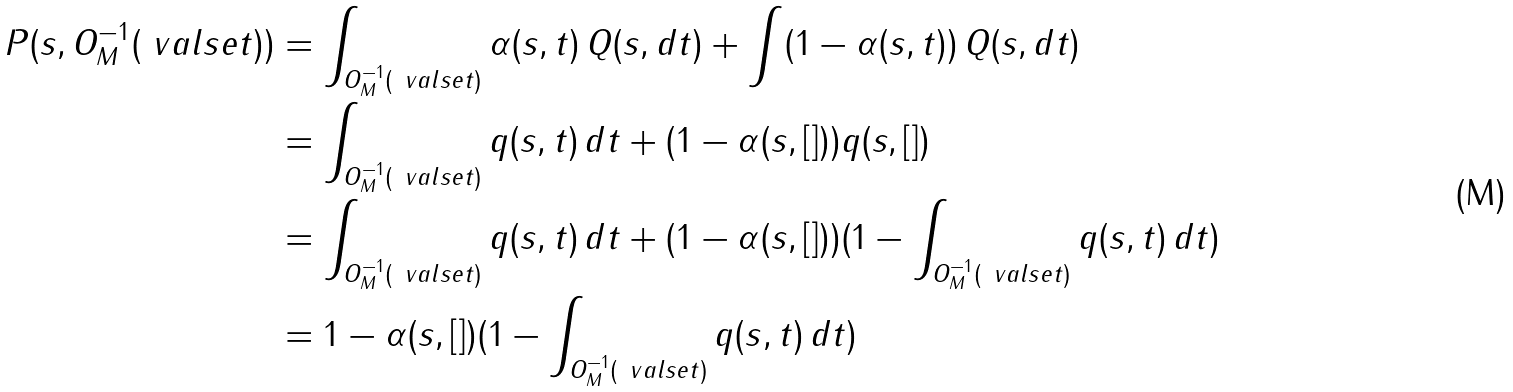Convert formula to latex. <formula><loc_0><loc_0><loc_500><loc_500>P ( s , O ^ { - 1 } _ { M } ( \ v a l s e t ) ) & = \int _ { O ^ { - 1 } _ { M } ( \ v a l s e t ) } \alpha ( s , t ) \, Q ( s , d t ) + \int ( 1 - \alpha ( s , t ) ) \, Q ( s , d t ) \\ & = \int _ { O ^ { - 1 } _ { M } ( \ v a l s e t ) } q ( s , t ) \, d t + ( 1 - \alpha ( s , [ ] ) ) q ( s , [ ] ) \\ & = \int _ { O ^ { - 1 } _ { M } ( \ v a l s e t ) } q ( s , t ) \, d t + ( 1 - \alpha ( s , [ ] ) ) ( 1 - \int _ { O ^ { - 1 } _ { M } ( \ v a l s e t ) } q ( s , t ) \, d t ) \\ & = 1 - \alpha ( s , [ ] ) ( 1 - \int _ { O ^ { - 1 } _ { M } ( \ v a l s e t ) } q ( s , t ) \, d t )</formula> 